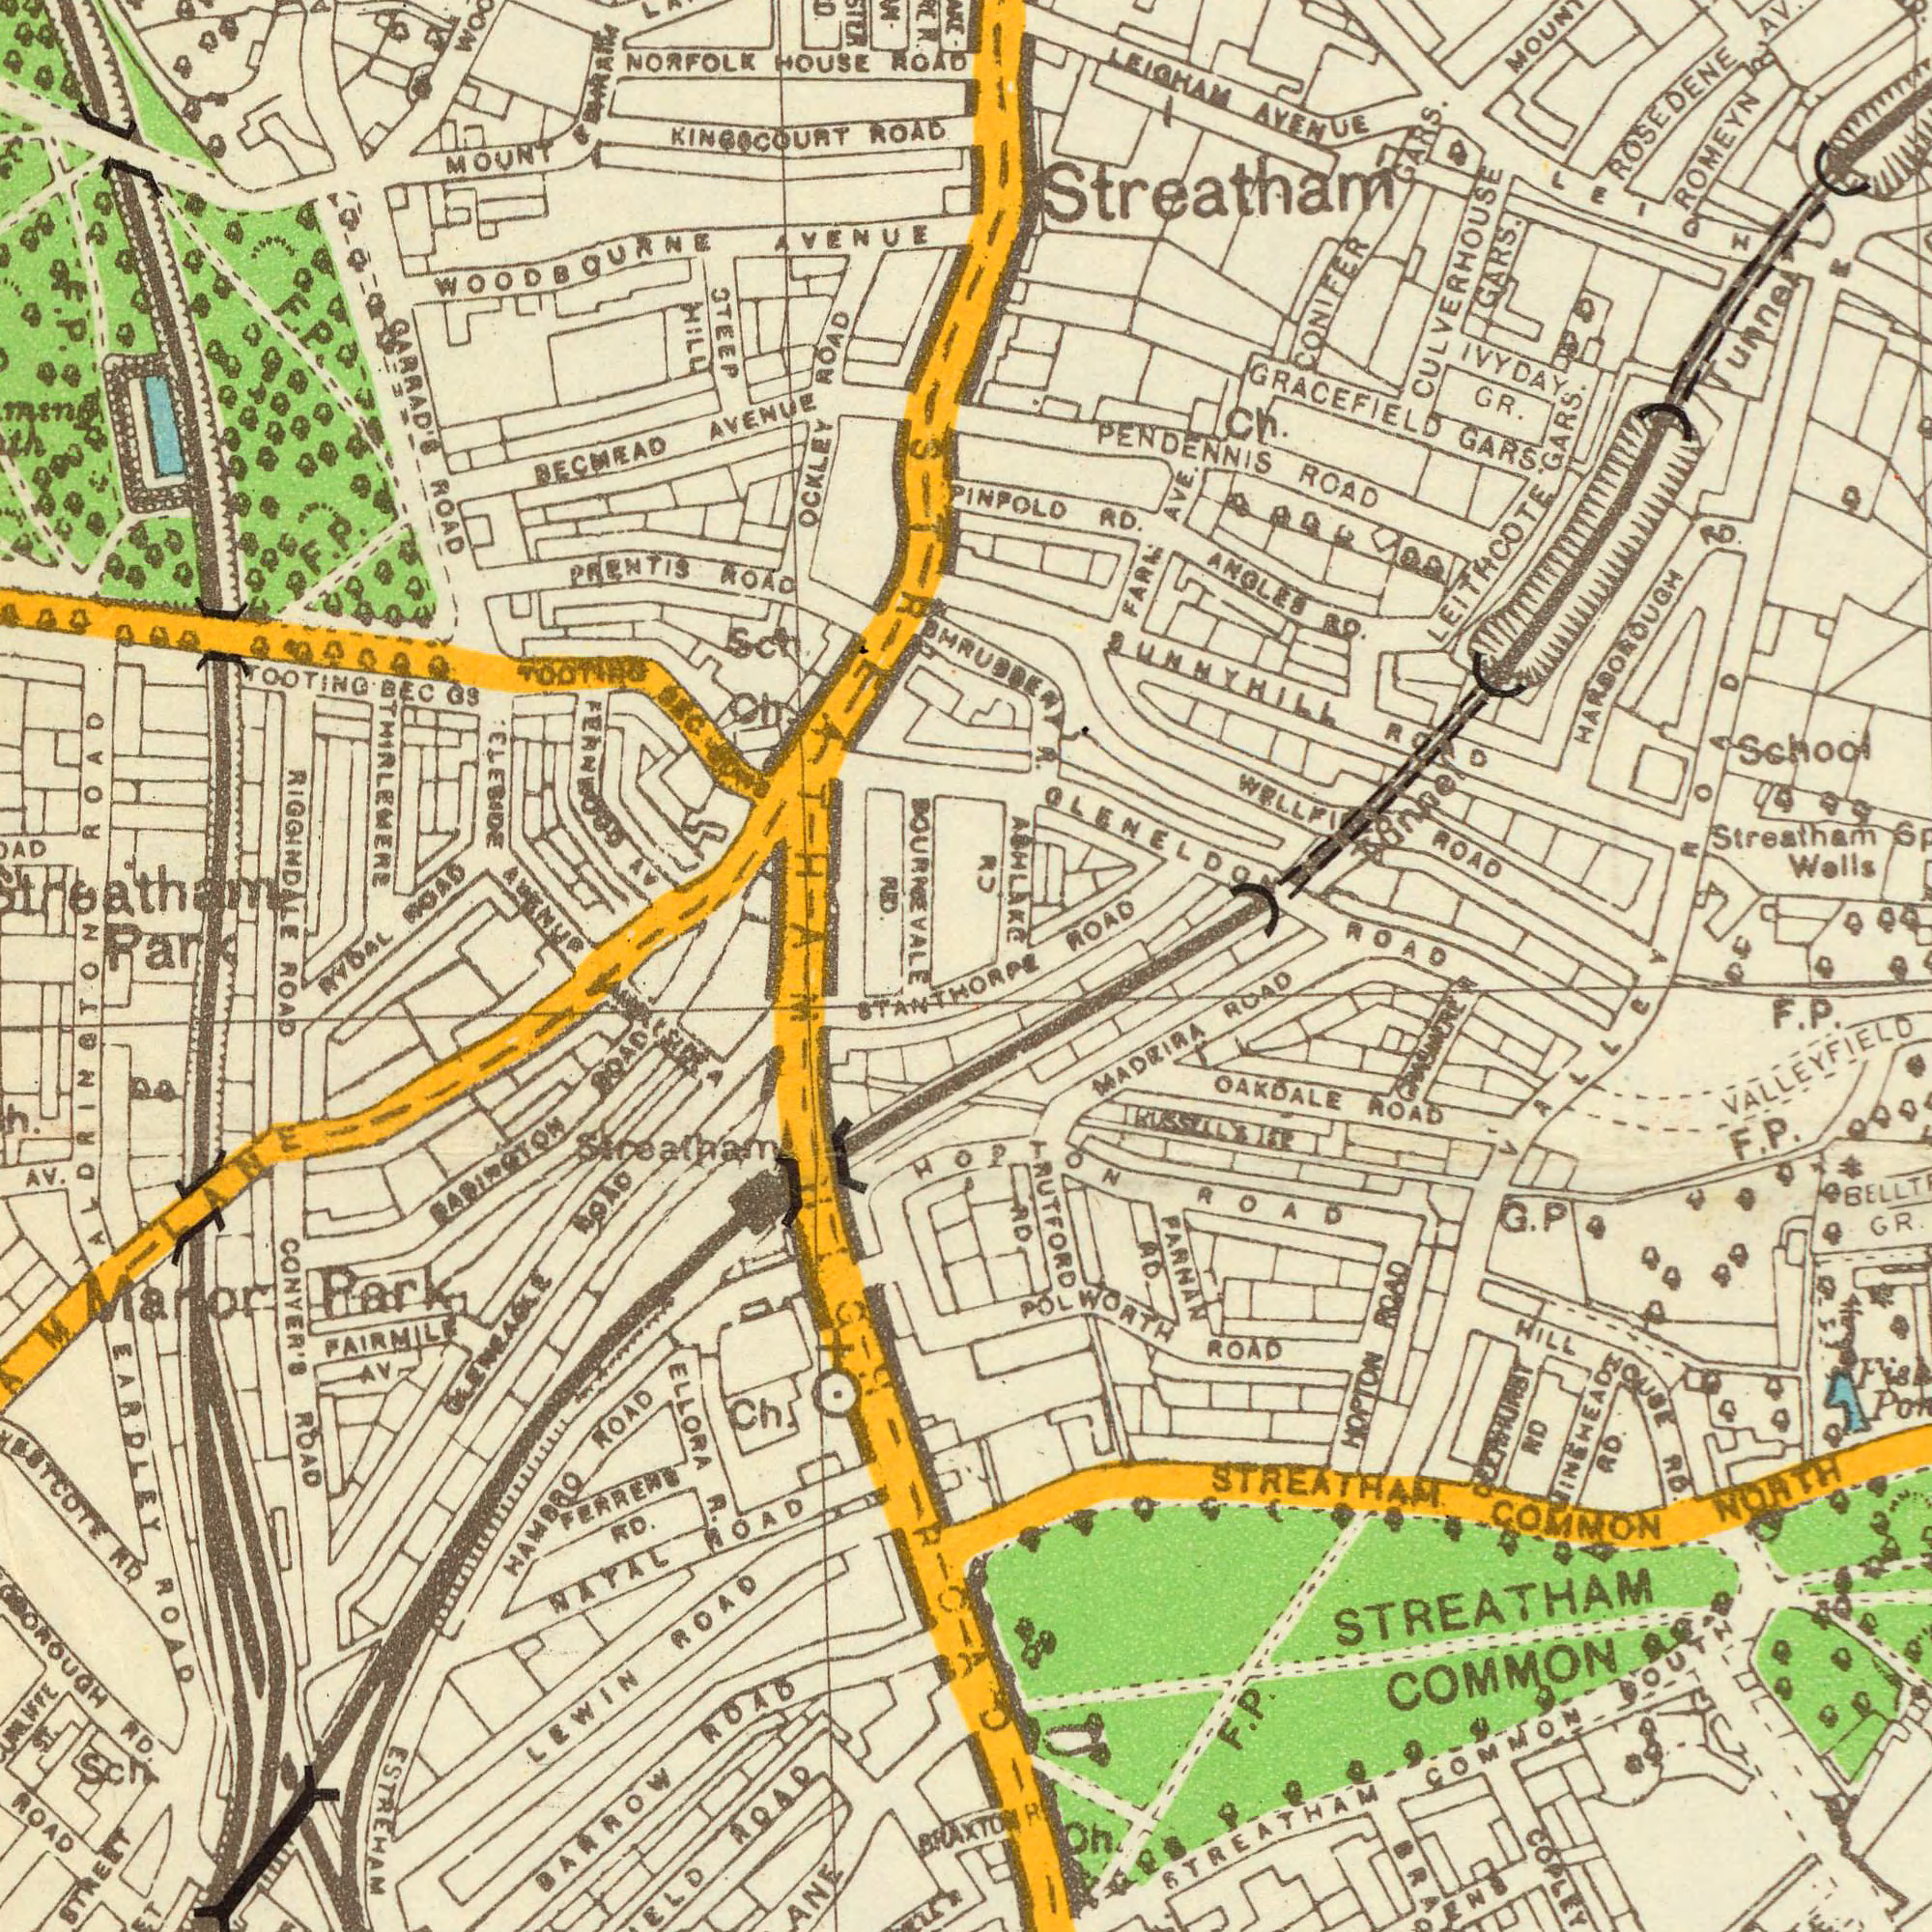What text appears in the bottom-right area of the image? VALLEY STREATHAM COMMON NORTH OAKDALE ROAD COPLEY MADEIRA ROAD HOPTON ROAD HOPTON ROAD GR. STREATHAM COMMON SOUTH STREATHAM COMMON POLWORTH ROAD VALLEYFIELD RUTFORD RD ###HURBI RD HILL HOUSE RD. PARNAN RD ###INEHEA### RD. Oh Fish RISSILLII F. P. F. P. G. P F. P. GARDENS BRAXTON R GRASMERE What text appears in the bottom-left area of the image? ROAD ALDRINGTON STANTHORPL CONYER'S ROAD ELLORA R. BABINGTON ROAD LEWIN ROAD NATAL ROAD HAMBRO ROAD PAIRMILE AV. RQAD AV. STREET BARROW ROAD FERRERS RD. Manor Park GLENEAGLE ROAD ROAD Streatham Ch. RD Sch ESTREHAM RD. EARDLEY ROAD ST. HIGH ROAD What text is visible in the upper-right corner? GLENELDON ROAD PENDENNIS ROAD ABHLAKE 0.694633 ANGLES RD. Streatham Wells ROMEYN ROAD School WELLFIELD ROAD FARM AVE. IVYDAY GR. Ch. PINPOLO RD. ROSEDENE LEIGHAM AVENUE GRACEFIELD GARS. HARBOROUGH RD. Streatham CULVERHOUSE GARS. BHRUBBENY R. SUNNYHILL ROAD LEITHCOTE GARS. CONIFER GARS. Tunnel ROAD LEIGHAM R Tunnel What text is shown in the top-left quadrant? RIGGINDALE KINGSCOURT ROAD NORFOLK HOUSE ROAD STEEP HILL BECMEAD AVENUE WOODBOURNE AVENUE OCKLEY ROAD TOOTING BEC GS GARRAD'S ROAD MOUNT AMBLESIDE AVENUE RYDAL ROAD BOURRE VALE RD FERNWOOD AV THIRLEMERE PRENTIS ROAD Sch. Streatham Park F. P. ROAD STREATHAM F. P. F. P. Ch. TOOTING BEC GDNS 